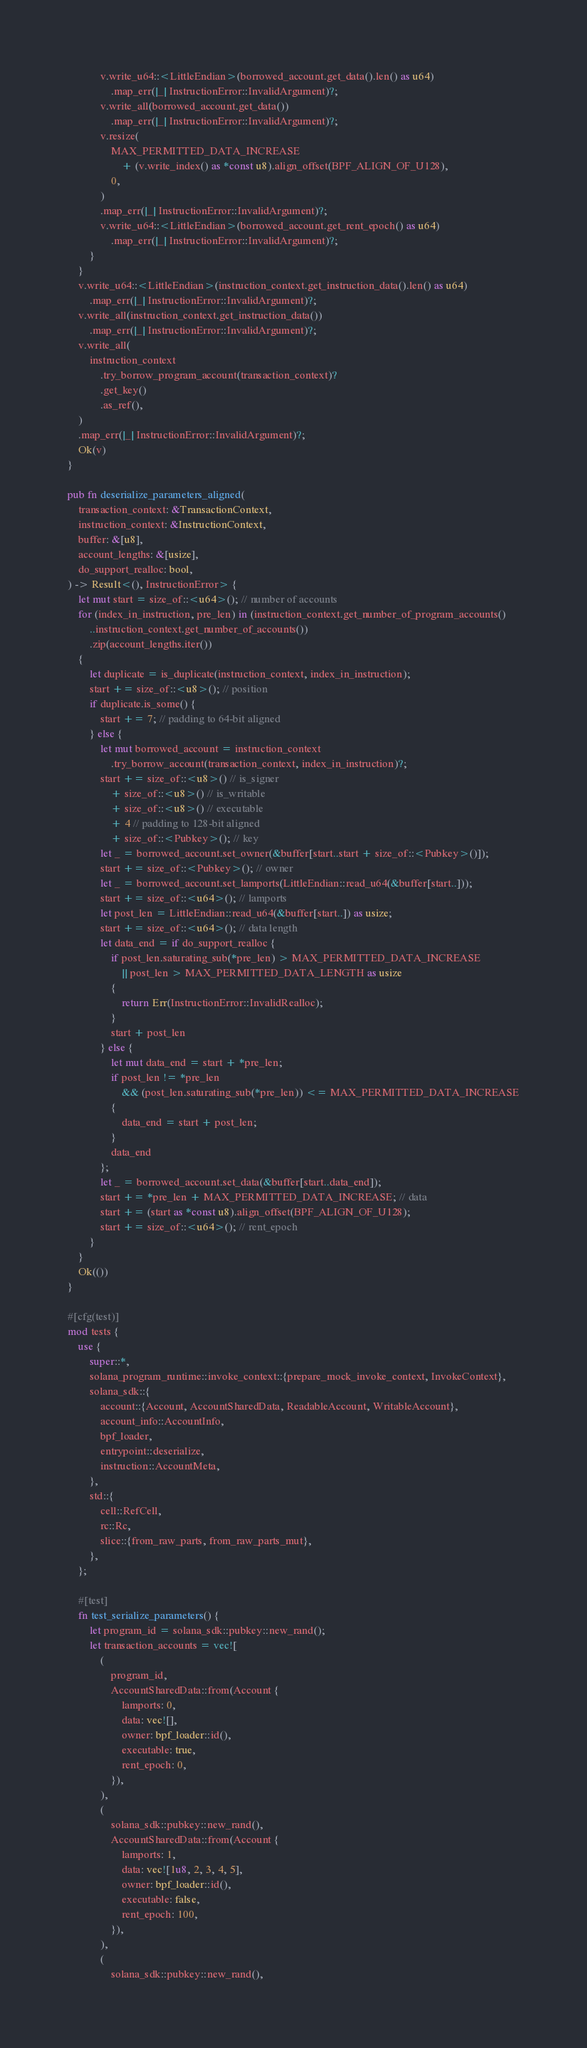<code> <loc_0><loc_0><loc_500><loc_500><_Rust_>            v.write_u64::<LittleEndian>(borrowed_account.get_data().len() as u64)
                .map_err(|_| InstructionError::InvalidArgument)?;
            v.write_all(borrowed_account.get_data())
                .map_err(|_| InstructionError::InvalidArgument)?;
            v.resize(
                MAX_PERMITTED_DATA_INCREASE
                    + (v.write_index() as *const u8).align_offset(BPF_ALIGN_OF_U128),
                0,
            )
            .map_err(|_| InstructionError::InvalidArgument)?;
            v.write_u64::<LittleEndian>(borrowed_account.get_rent_epoch() as u64)
                .map_err(|_| InstructionError::InvalidArgument)?;
        }
    }
    v.write_u64::<LittleEndian>(instruction_context.get_instruction_data().len() as u64)
        .map_err(|_| InstructionError::InvalidArgument)?;
    v.write_all(instruction_context.get_instruction_data())
        .map_err(|_| InstructionError::InvalidArgument)?;
    v.write_all(
        instruction_context
            .try_borrow_program_account(transaction_context)?
            .get_key()
            .as_ref(),
    )
    .map_err(|_| InstructionError::InvalidArgument)?;
    Ok(v)
}

pub fn deserialize_parameters_aligned(
    transaction_context: &TransactionContext,
    instruction_context: &InstructionContext,
    buffer: &[u8],
    account_lengths: &[usize],
    do_support_realloc: bool,
) -> Result<(), InstructionError> {
    let mut start = size_of::<u64>(); // number of accounts
    for (index_in_instruction, pre_len) in (instruction_context.get_number_of_program_accounts()
        ..instruction_context.get_number_of_accounts())
        .zip(account_lengths.iter())
    {
        let duplicate = is_duplicate(instruction_context, index_in_instruction);
        start += size_of::<u8>(); // position
        if duplicate.is_some() {
            start += 7; // padding to 64-bit aligned
        } else {
            let mut borrowed_account = instruction_context
                .try_borrow_account(transaction_context, index_in_instruction)?;
            start += size_of::<u8>() // is_signer
                + size_of::<u8>() // is_writable
                + size_of::<u8>() // executable
                + 4 // padding to 128-bit aligned
                + size_of::<Pubkey>(); // key
            let _ = borrowed_account.set_owner(&buffer[start..start + size_of::<Pubkey>()]);
            start += size_of::<Pubkey>(); // owner
            let _ = borrowed_account.set_lamports(LittleEndian::read_u64(&buffer[start..]));
            start += size_of::<u64>(); // lamports
            let post_len = LittleEndian::read_u64(&buffer[start..]) as usize;
            start += size_of::<u64>(); // data length
            let data_end = if do_support_realloc {
                if post_len.saturating_sub(*pre_len) > MAX_PERMITTED_DATA_INCREASE
                    || post_len > MAX_PERMITTED_DATA_LENGTH as usize
                {
                    return Err(InstructionError::InvalidRealloc);
                }
                start + post_len
            } else {
                let mut data_end = start + *pre_len;
                if post_len != *pre_len
                    && (post_len.saturating_sub(*pre_len)) <= MAX_PERMITTED_DATA_INCREASE
                {
                    data_end = start + post_len;
                }
                data_end
            };
            let _ = borrowed_account.set_data(&buffer[start..data_end]);
            start += *pre_len + MAX_PERMITTED_DATA_INCREASE; // data
            start += (start as *const u8).align_offset(BPF_ALIGN_OF_U128);
            start += size_of::<u64>(); // rent_epoch
        }
    }
    Ok(())
}

#[cfg(test)]
mod tests {
    use {
        super::*,
        solana_program_runtime::invoke_context::{prepare_mock_invoke_context, InvokeContext},
        solana_sdk::{
            account::{Account, AccountSharedData, ReadableAccount, WritableAccount},
            account_info::AccountInfo,
            bpf_loader,
            entrypoint::deserialize,
            instruction::AccountMeta,
        },
        std::{
            cell::RefCell,
            rc::Rc,
            slice::{from_raw_parts, from_raw_parts_mut},
        },
    };

    #[test]
    fn test_serialize_parameters() {
        let program_id = solana_sdk::pubkey::new_rand();
        let transaction_accounts = vec![
            (
                program_id,
                AccountSharedData::from(Account {
                    lamports: 0,
                    data: vec![],
                    owner: bpf_loader::id(),
                    executable: true,
                    rent_epoch: 0,
                }),
            ),
            (
                solana_sdk::pubkey::new_rand(),
                AccountSharedData::from(Account {
                    lamports: 1,
                    data: vec![1u8, 2, 3, 4, 5],
                    owner: bpf_loader::id(),
                    executable: false,
                    rent_epoch: 100,
                }),
            ),
            (
                solana_sdk::pubkey::new_rand(),</code> 